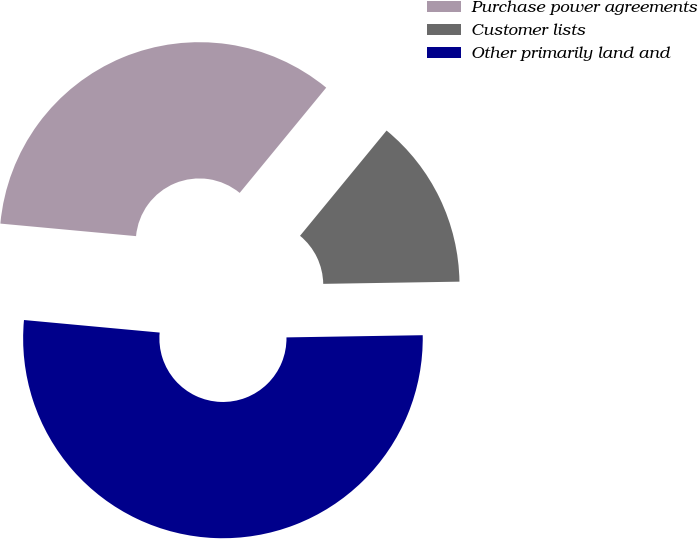Convert chart. <chart><loc_0><loc_0><loc_500><loc_500><pie_chart><fcel>Purchase power agreements<fcel>Customer lists<fcel>Other primarily land and<nl><fcel>34.48%<fcel>13.79%<fcel>51.72%<nl></chart> 